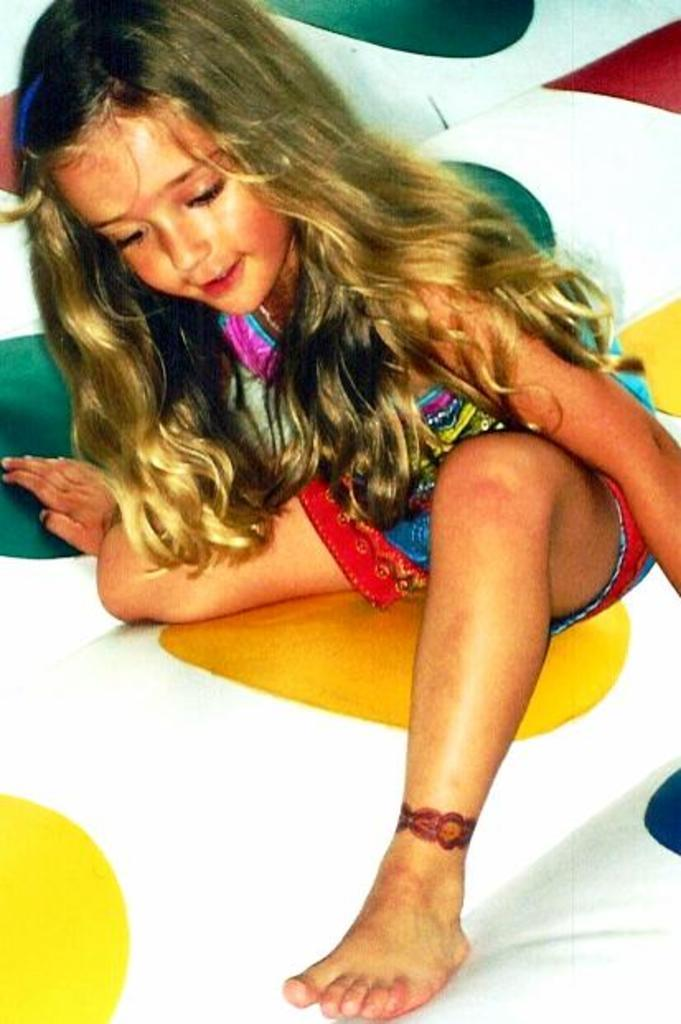Who is the main subject in the image? There is a girl in the image. What is the girl's facial expression? The girl has a smiling face. Where is the girl sitting in the image? The girl is sitting on a white surface. What can be observed on the white surface? The white surface has colorful dots. What is the rate of the bikes passing by in the image? There are no bikes present in the image, so it is not possible to determine the rate at which they might pass by. 